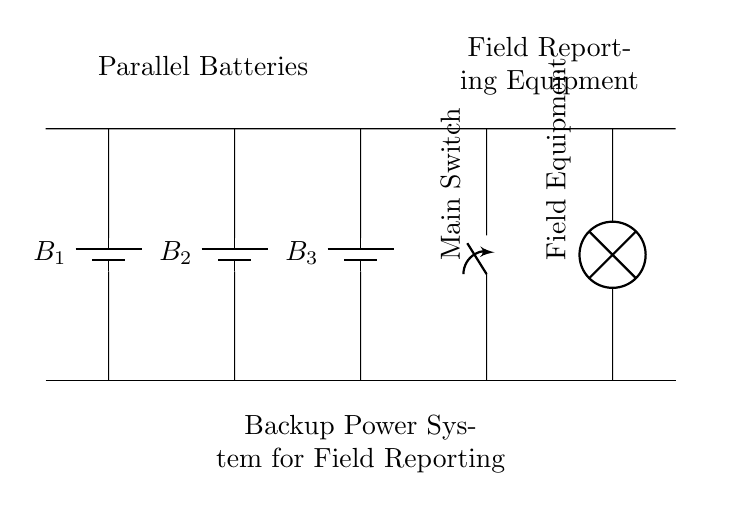What components are in the circuit? The circuit includes three batteries and one switch along with a load. The batteries are labeled B1, B2, and B3, while the load is the field equipment.
Answer: three batteries, one switch, and one load What is the function of the switch? The switch in this circuit acts as a control mechanism to connect or disconnect the entire circuit, thereby allowing the field reporting equipment to be powered or turned off as needed.
Answer: control mechanism How many batteries are connected in parallel? The diagram shows a total of three batteries connected in parallel. This is evident from their configuration, where all positive terminals are connected, and all negative terminals are connected.
Answer: three What is the purpose of connecting batteries in parallel? Connecting batteries in parallel increases the total capacity (amp-hours) while maintaining the same voltage. This is important for providing backup power, especially for equipment which requires a long operational duration.
Answer: increase capacity What happens if one battery fails in this parallel configuration? If one battery fails in this parallel configuration, the other batteries can still provide power, allowing the system to remain operational, although the total capacity may be reduced.
Answer: system remains operational What voltage do the batteries provide? Each battery provides a voltage equal to its rated voltage, which is typically twelve volts, and the total voltage in a parallel configuration remains the same as one battery.
Answer: twelve volts What type of circuit is represented in the diagram? The circuit shown is a parallel circuit, which is characterized by multiple connections across the same two points and allows each branch to operate independently.
Answer: parallel circuit 